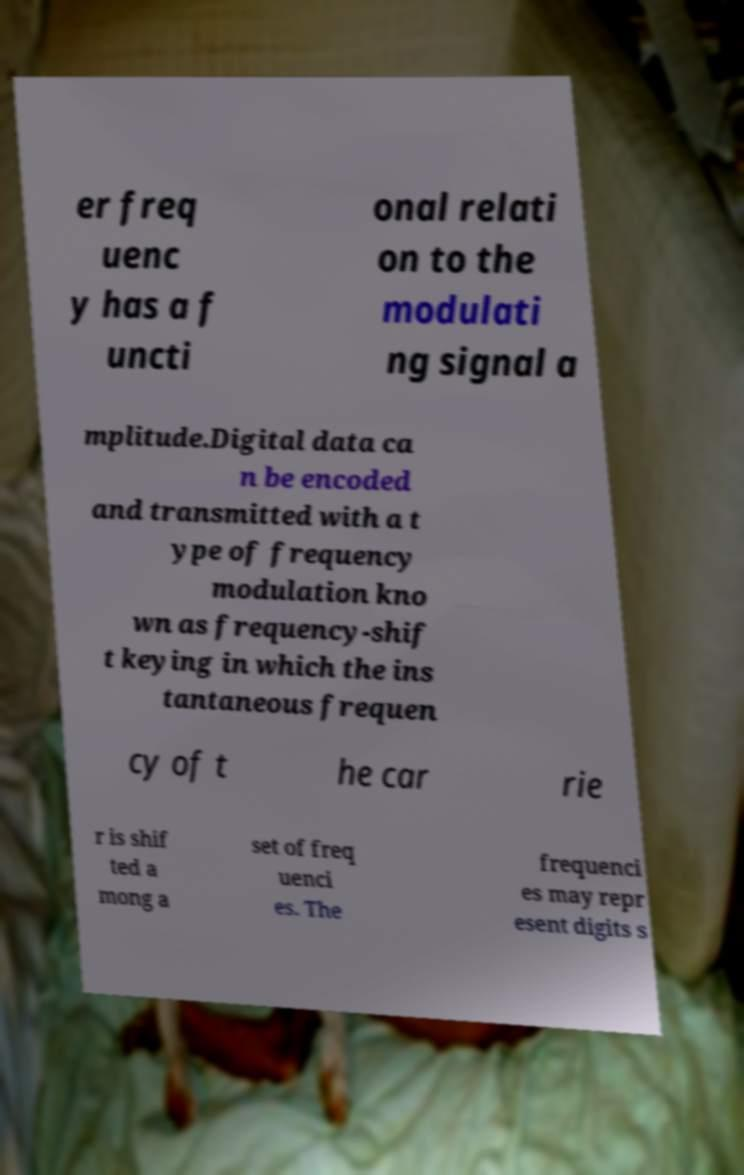Could you assist in decoding the text presented in this image and type it out clearly? er freq uenc y has a f uncti onal relati on to the modulati ng signal a mplitude.Digital data ca n be encoded and transmitted with a t ype of frequency modulation kno wn as frequency-shif t keying in which the ins tantaneous frequen cy of t he car rie r is shif ted a mong a set of freq uenci es. The frequenci es may repr esent digits s 